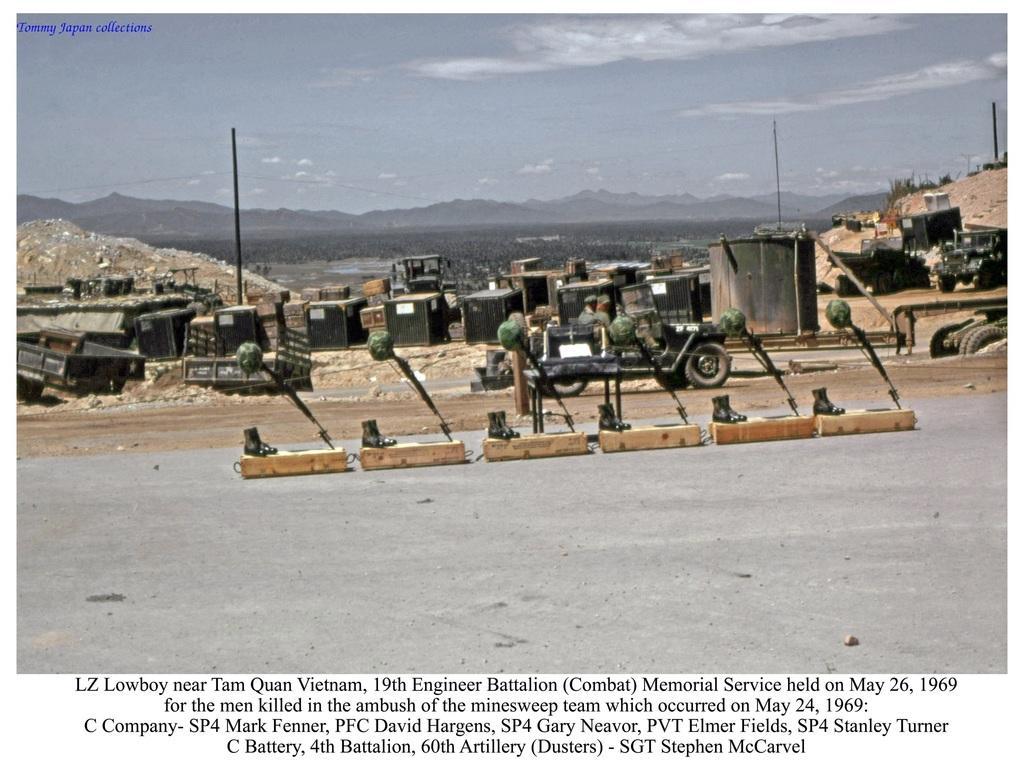In one or two sentences, can you explain what this image depicts? In the center of the image there are vehicles and we can see people sitting in the vehicles. At the bottom there is a road and we can see things placed on the road. In the background there are blocks, poles, hills and sky. At the bottom there is text. 